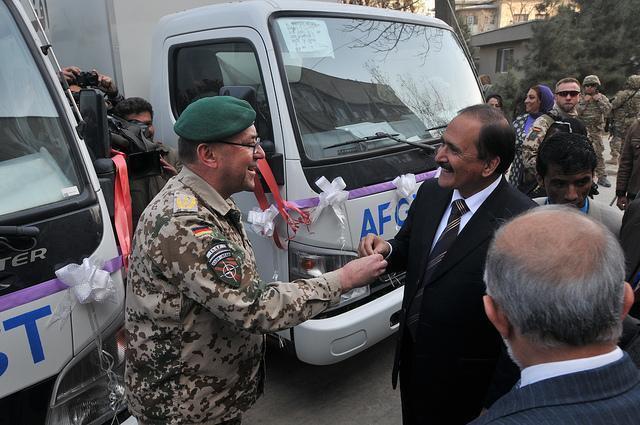How many people are there?
Give a very brief answer. 4. How many trucks are there?
Give a very brief answer. 2. 